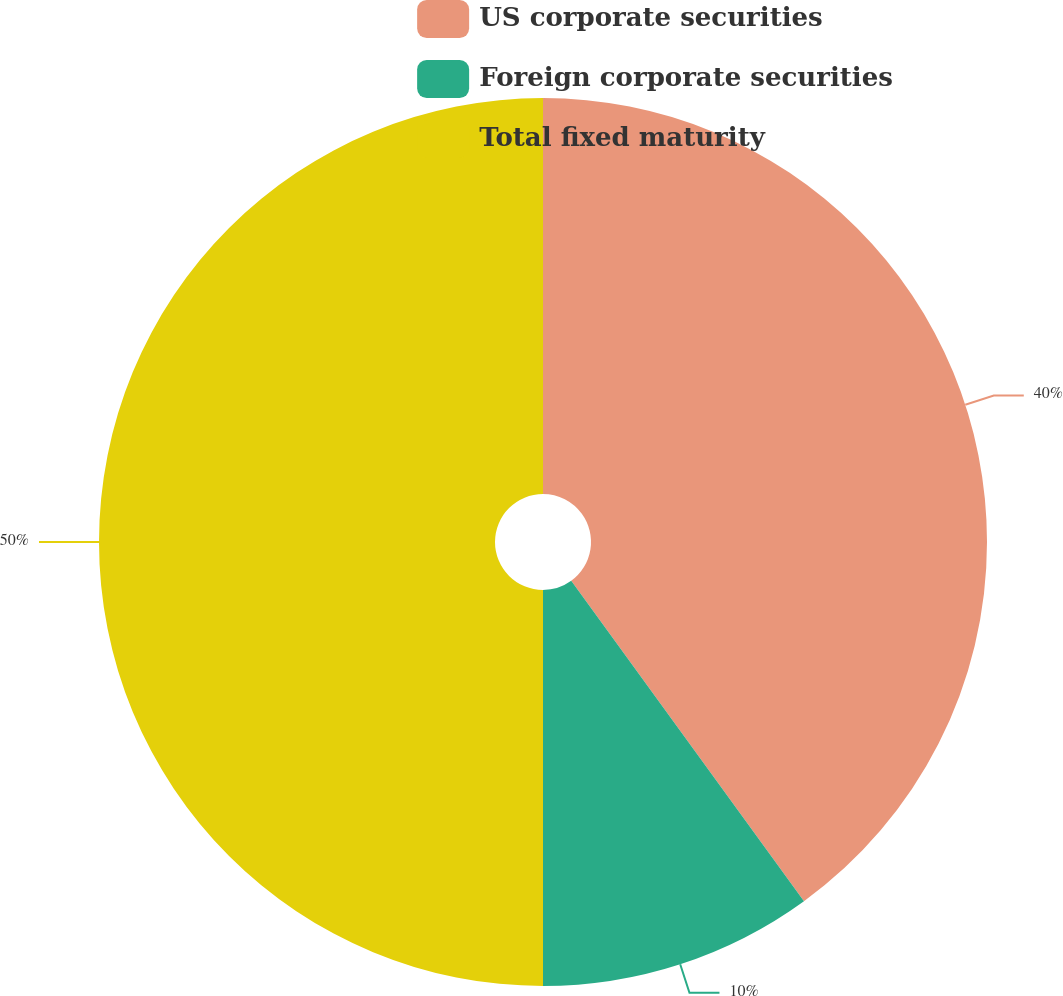<chart> <loc_0><loc_0><loc_500><loc_500><pie_chart><fcel>US corporate securities<fcel>Foreign corporate securities<fcel>Total fixed maturity<nl><fcel>40.0%<fcel>10.0%<fcel>50.0%<nl></chart> 